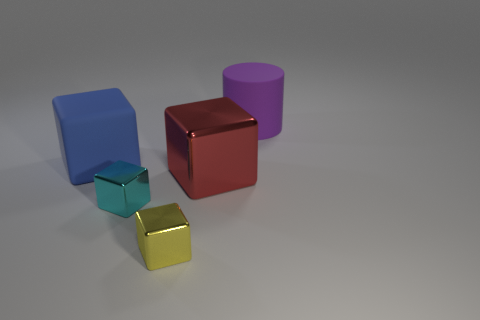Subtract all cyan blocks. How many blocks are left? 3 Subtract all blue cubes. How many cubes are left? 3 Subtract all purple cubes. Subtract all gray cylinders. How many cubes are left? 4 Add 2 blue matte things. How many objects exist? 7 Subtract all blocks. How many objects are left? 1 Add 5 large red shiny cubes. How many large red shiny cubes are left? 6 Add 5 blue cubes. How many blue cubes exist? 6 Subtract 0 green cylinders. How many objects are left? 5 Subtract all purple cylinders. Subtract all yellow metal things. How many objects are left? 3 